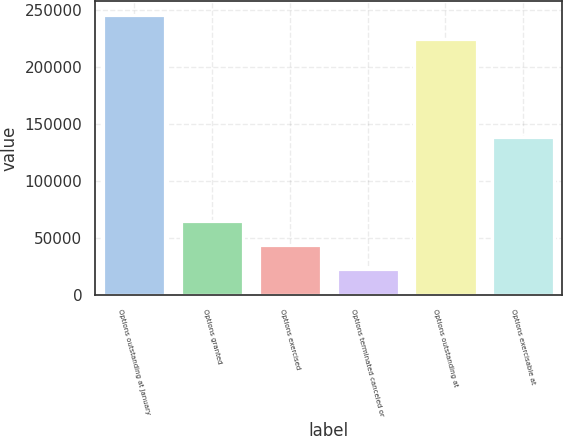Convert chart. <chart><loc_0><loc_0><loc_500><loc_500><bar_chart><fcel>Options outstanding at January<fcel>Options granted<fcel>Options exercised<fcel>Options terminated canceled or<fcel>Options outstanding at<fcel>Options exercisable at<nl><fcel>245276<fcel>65277.8<fcel>44256.9<fcel>23236<fcel>224255<fcel>138741<nl></chart> 